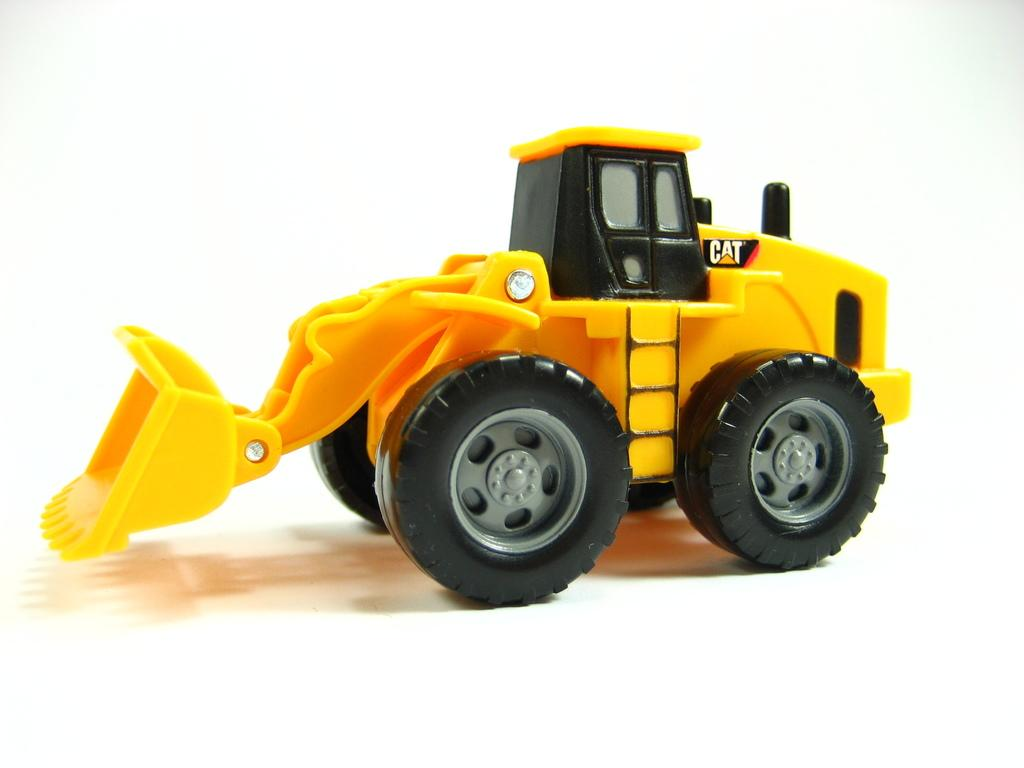What type of toy is in the image? There is a toy truck in the image. Can you describe the position of the toy truck in the image? The toy truck is placed on a surface. What memory does the toy truck trigger for the person looking at the image? The image does not provide any information about the person looking at it or any memories they might have, so it is impossible to answer this question. 